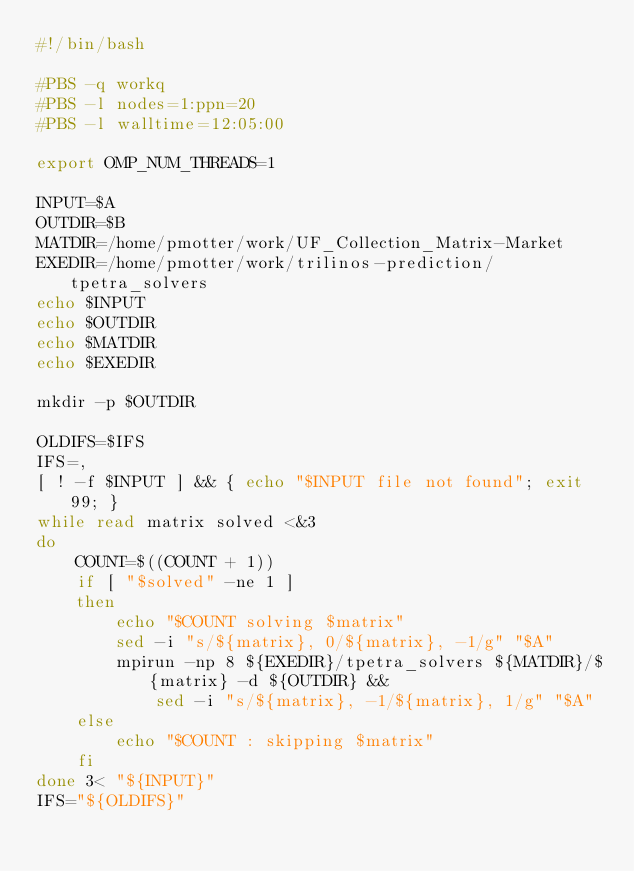<code> <loc_0><loc_0><loc_500><loc_500><_Bash_>#!/bin/bash

#PBS -q workq
#PBS -l nodes=1:ppn=20
#PBS -l walltime=12:05:00

export OMP_NUM_THREADS=1

INPUT=$A
OUTDIR=$B
MATDIR=/home/pmotter/work/UF_Collection_Matrix-Market
EXEDIR=/home/pmotter/work/trilinos-prediction/tpetra_solvers
echo $INPUT
echo $OUTDIR
echo $MATDIR
echo $EXEDIR

mkdir -p $OUTDIR

OLDIFS=$IFS
IFS=,
[ ! -f $INPUT ] && { echo "$INPUT file not found"; exit 99; }
while read matrix solved <&3
do
    COUNT=$((COUNT + 1))
    if [ "$solved" -ne 1 ]
    then
        echo "$COUNT solving $matrix"
        sed -i "s/${matrix}, 0/${matrix}, -1/g" "$A"
        mpirun -np 8 ${EXEDIR}/tpetra_solvers ${MATDIR}/${matrix} -d ${OUTDIR} && 
            sed -i "s/${matrix}, -1/${matrix}, 1/g" "$A"
    else
        echo "$COUNT : skipping $matrix"
    fi
done 3< "${INPUT}"
IFS="${OLDIFS}"
</code> 